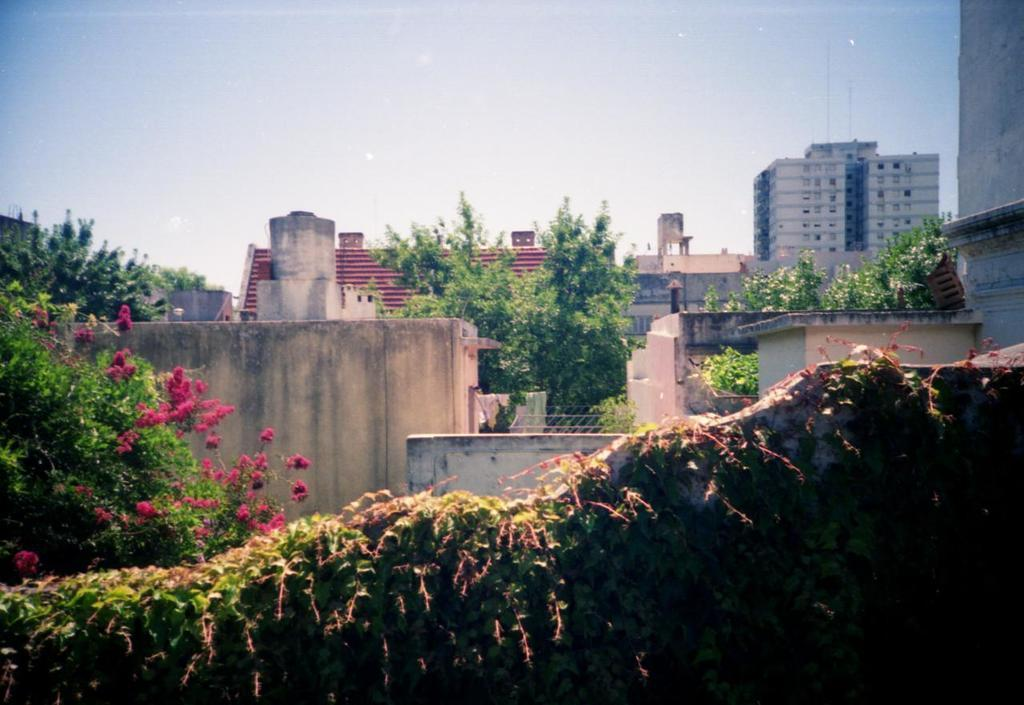What type of structures can be seen in the image? There are buildings in the image. What is being used for cooking in the image? There is a grill in the image. What type of items are visible in the image? Clothes and creepers are present in the image. What type of vegetation can be seen in the image? Trees and plants are in the image. What part of the natural environment is visible in the image? The sky is visible in the image. What type of feather can be seen on the income in the image? There is no feather or income present in the image. How does the mass of the buildings affect the stability of the trees in the image? There is no information about the mass of the buildings or the stability of the trees in the image. 